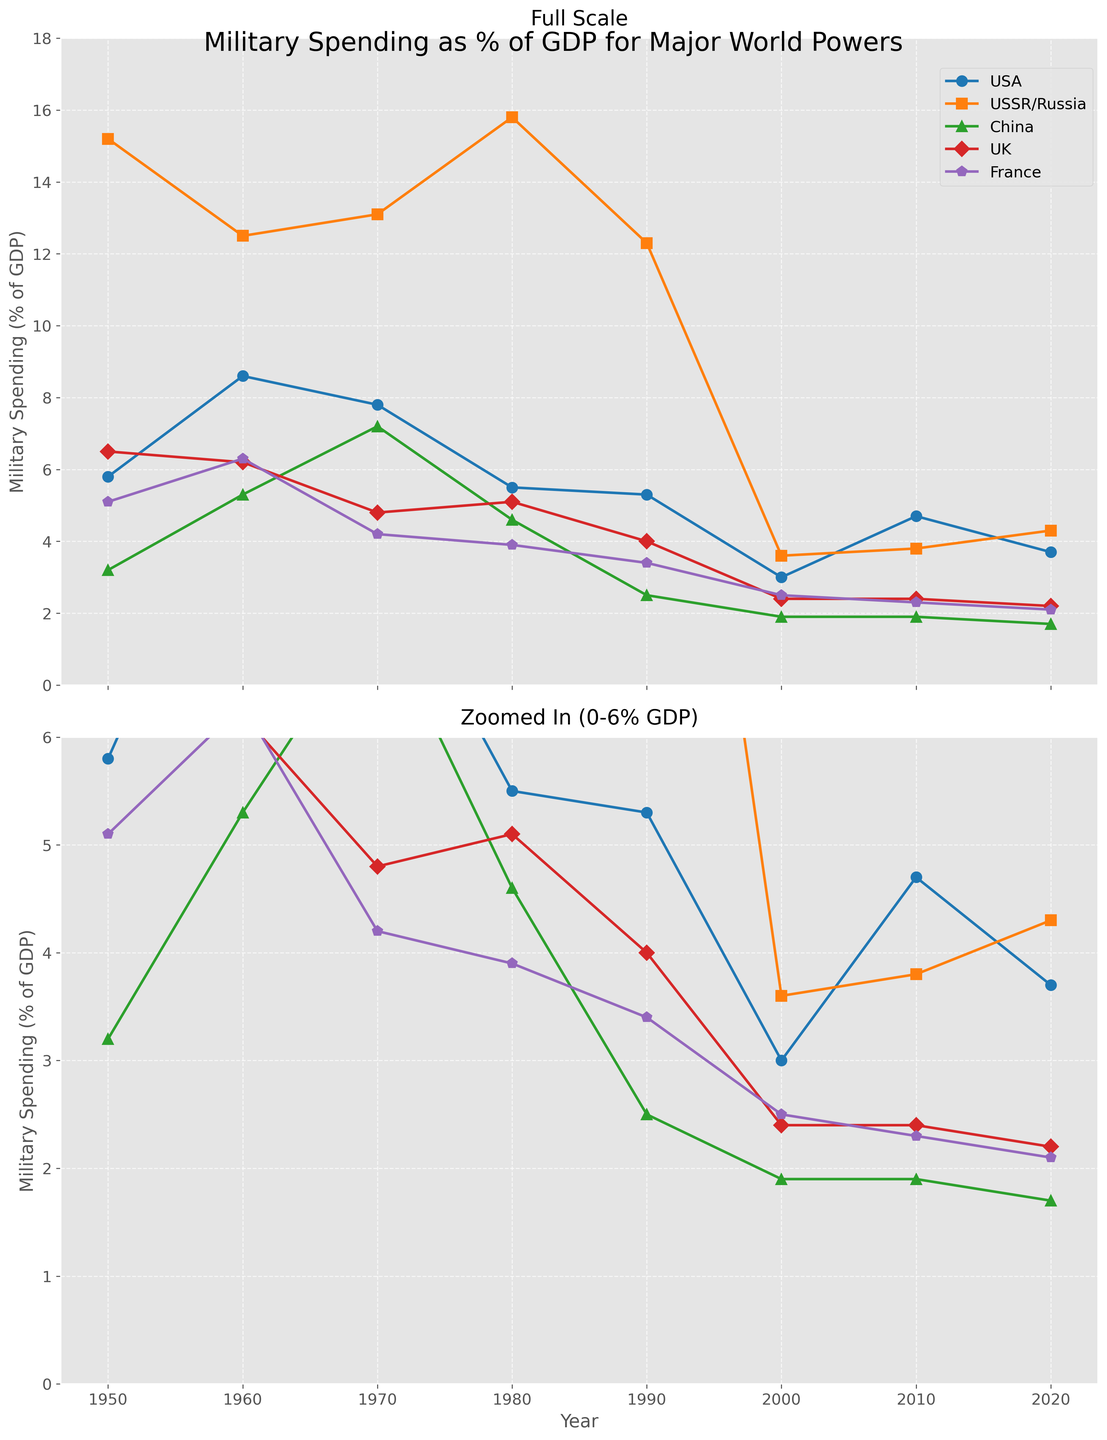What is the title of the figure? The title of the figure can be found at the top, centered, and in a larger font. It reads 'Military Spending as % of GDP for Major World Powers'.
Answer: Military Spending as % of GDP for Major World Powers What years are covered in the figure? The x-axis, labeled 'Year', spans from 1950 to 2020 as indicated by the tick marks and labels on the axis.
Answer: 1950 to 2020 Which country had the highest military spending as a percentage of GDP in the 1950s? In the plot labeled 'Full Scale', the peak value in the 1950s is indicated by the line for USSR/Russia which reaches 15.2%.
Answer: USSR/Russia What's the trend in military spending as % of GDP for the USA from 1950 to 2020? The USA's line shows a high point in the 1960s, followed by a general decline with some fluctuations, notably rising again around 2010.
Answer: Fluctuating with a general decline Which country showed a noticeable increase in military spending as % of GDP around the 1970s? Referring to the plot, China's line rises significantly around the 1970s, indicating a noticeable increase.
Answer: China By how much did the military spending as a % of GDP for USSR/Russia decrease from its peak to 2000? USSR/Russia's peak value is 15.8% in the 1980s. By 2000, this value drops to 3.6%. The decrease is 15.8% - 3.6% = 12.2%.
Answer: 12.2% Which country spends the least on military as % of GDP in 2020 as shown in the figure? In the 'Zoomed In' subplot, China's line is the lowest at 1.7% in 2020.
Answer: China Comparing 1980 and 2020, which country had a more significant decrease in military spending as % of GDP, the UK or France? In 1980, UK was at 5.1%, and by 2020 it was 2.2%. France was at 3.9% in 1980, decreasing to 2.1% in 2020. The UK had a decrease of 2.9% and France 1.8%. Hence, the UK had a more significant decrease.
Answer: UK At which point did the USA experience its lowest military spending as % of GDP and what was the percentage? The lowest point for the USA, found in the 'Zoomed In' subplot, is in the year 2000 with 3.0%.
Answer: 2000, 3.0% How does the military spending trend of the UK compare to France from 1950 to 2020? Both the UK and France show a decreasing trend in military spending as % of GDP from 1950 to 2020. However, the UK's values decrease more sharply than France's over this period.
Answer: Both decreased, UK more sharply 